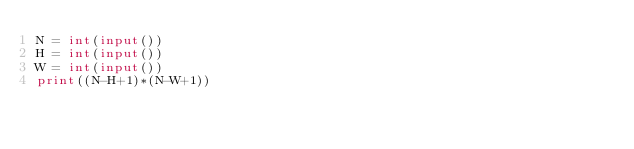Convert code to text. <code><loc_0><loc_0><loc_500><loc_500><_Python_>N = int(input())
H = int(input())
W = int(input())
print((N-H+1)*(N-W+1))</code> 